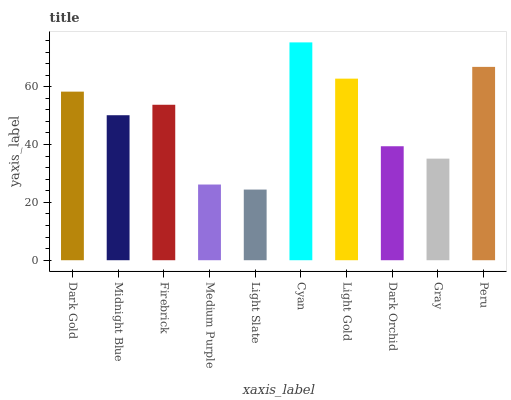Is Light Slate the minimum?
Answer yes or no. Yes. Is Cyan the maximum?
Answer yes or no. Yes. Is Midnight Blue the minimum?
Answer yes or no. No. Is Midnight Blue the maximum?
Answer yes or no. No. Is Dark Gold greater than Midnight Blue?
Answer yes or no. Yes. Is Midnight Blue less than Dark Gold?
Answer yes or no. Yes. Is Midnight Blue greater than Dark Gold?
Answer yes or no. No. Is Dark Gold less than Midnight Blue?
Answer yes or no. No. Is Firebrick the high median?
Answer yes or no. Yes. Is Midnight Blue the low median?
Answer yes or no. Yes. Is Dark Gold the high median?
Answer yes or no. No. Is Dark Gold the low median?
Answer yes or no. No. 